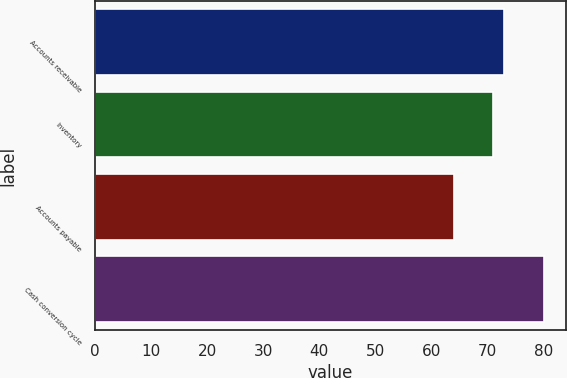Convert chart. <chart><loc_0><loc_0><loc_500><loc_500><bar_chart><fcel>Accounts receivable<fcel>Inventory<fcel>Accounts payable<fcel>Cash conversion cycle<nl><fcel>73<fcel>71<fcel>64<fcel>80<nl></chart> 